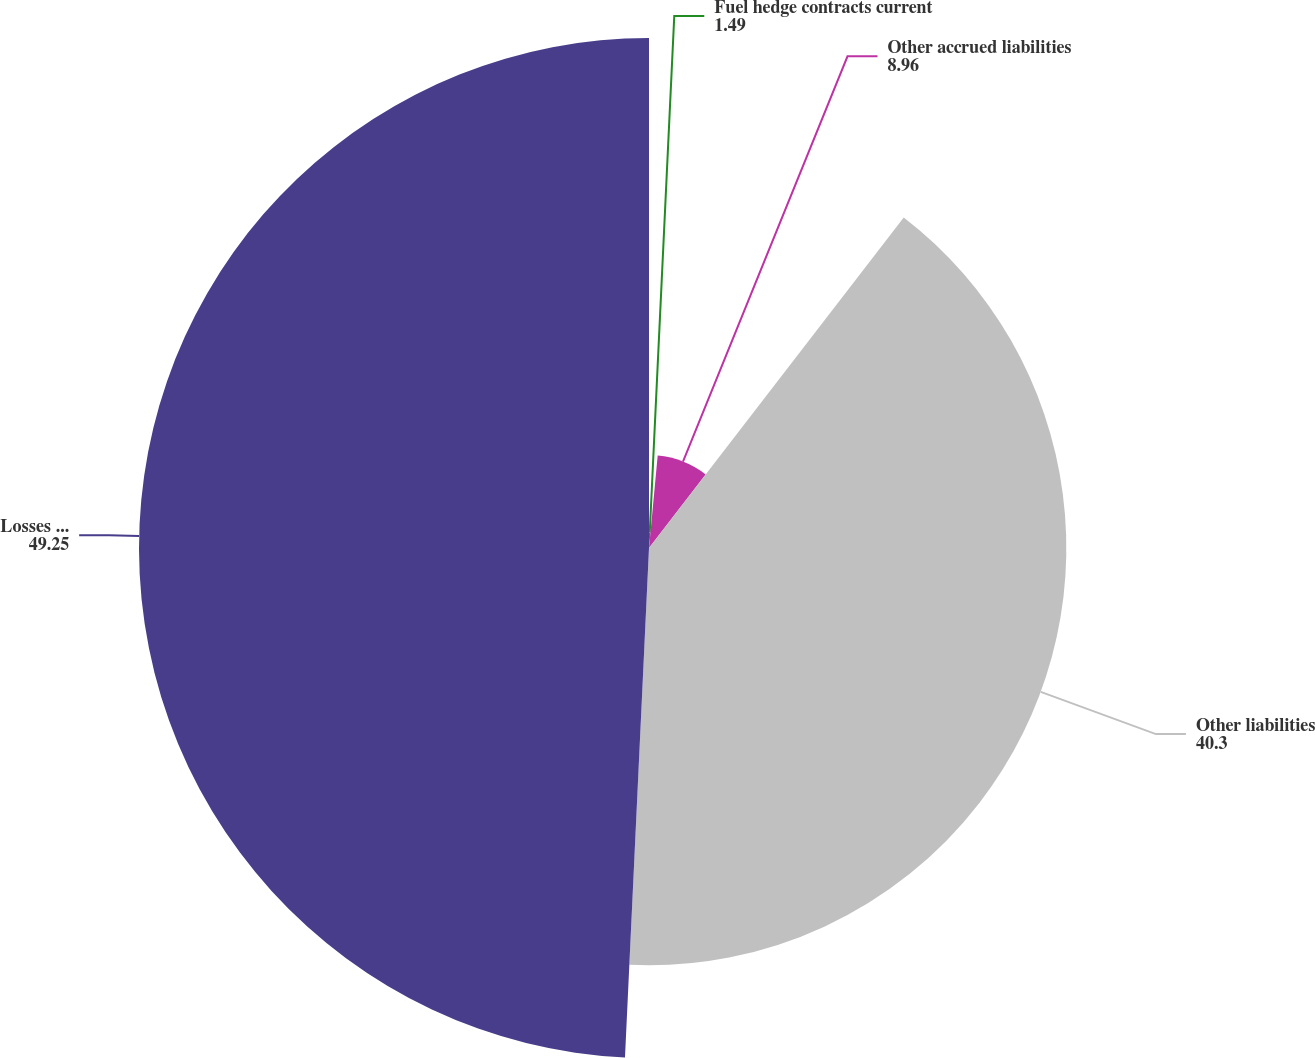Convert chart to OTSL. <chart><loc_0><loc_0><loc_500><loc_500><pie_chart><fcel>Fuel hedge contracts current<fcel>Other accrued liabilities<fcel>Other liabilities<fcel>Losses in accumulated other<nl><fcel>1.49%<fcel>8.96%<fcel>40.3%<fcel>49.25%<nl></chart> 